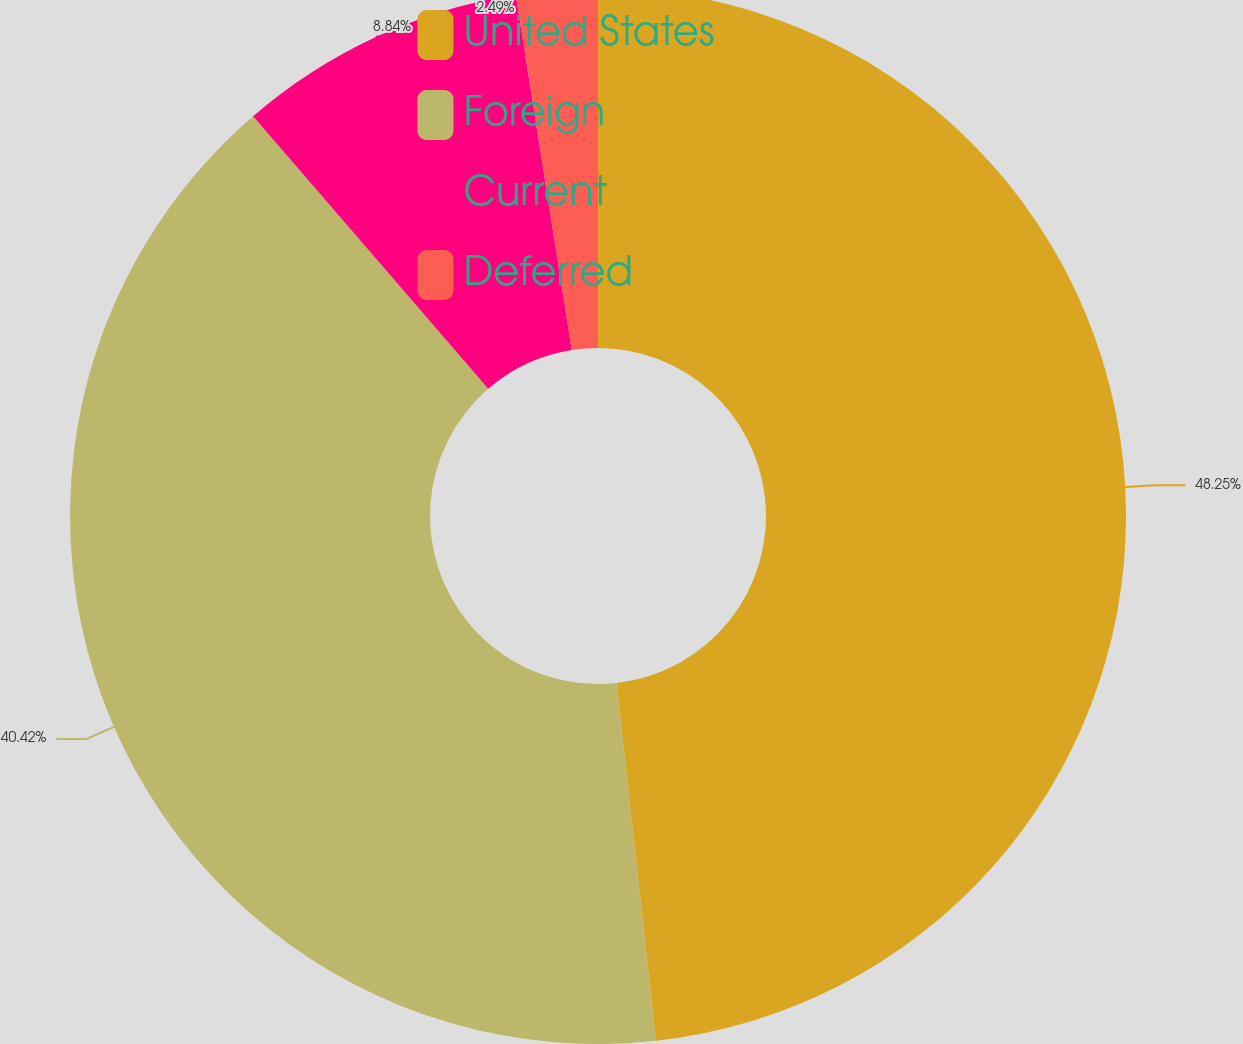Convert chart. <chart><loc_0><loc_0><loc_500><loc_500><pie_chart><fcel>United States<fcel>Foreign<fcel>Current<fcel>Deferred<nl><fcel>48.25%<fcel>40.42%<fcel>8.84%<fcel>2.49%<nl></chart> 